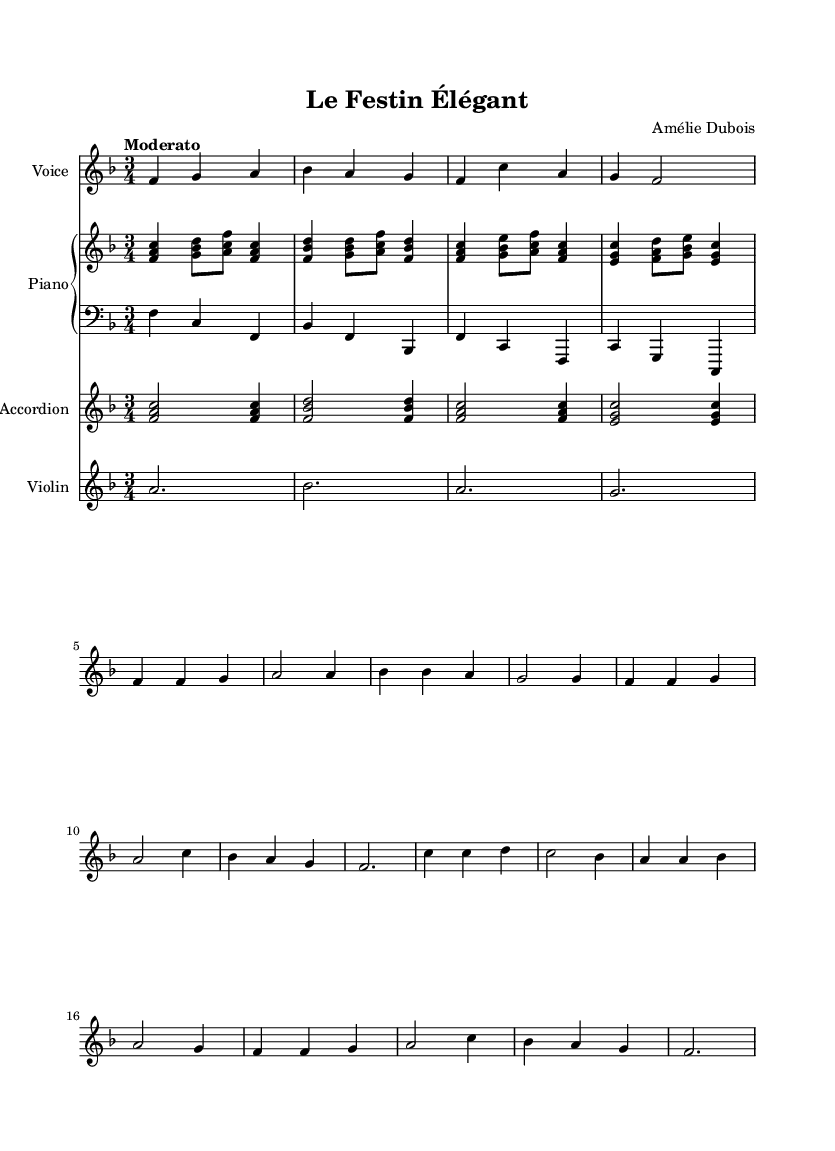What is the key signature of this music? The key signature in the score indicates one flat, specifically B flat, which confirms it is in F major.
Answer: F major What is the time signature of this music? The time signature shown at the beginning of the sheet indicates three beats per measure, represented by 3 over 4.
Answer: 3/4 What is the tempo marking in the score? The tempo marking is specified as "Moderato," indicating a moderate speed for the piece.
Answer: Moderato How many measures are in the verse section? By counting the measures marked in the verse section, there are a total of four measures present.
Answer: 4 What instruments are included in this piece? The score features a voice, piano, accordion, and violin as the instruments used in the composition.
Answer: Voice, piano, accordion, violin What phrase is repeated in the chorus? The phrase "C'est la fête, c'est le plaisir partagé" is a notable line in the chorus, indicating the theme of celebration.
Answer: C'est la fête, c'est le plaisir partagé What is the primary theme of the lyrics in this piece? The lyrics celebrate the joy of dining and entertaining, reflecting the culture of hosting and enjoying meals together.
Answer: Joy of dining and entertaining 